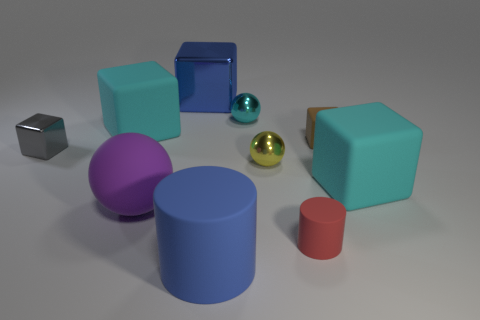There is a cyan object that is on the left side of the small red cylinder and right of the big blue cylinder; what is its size?
Your answer should be compact. Small. Are there fewer tiny yellow metal things to the left of the yellow metal thing than small yellow spheres?
Keep it short and to the point. Yes. Are the big cylinder and the big blue block made of the same material?
Offer a terse response. No. What number of objects are either tiny brown cubes or large blue metallic objects?
Make the answer very short. 2. What number of big cubes have the same material as the yellow thing?
Make the answer very short. 1. The blue object that is the same shape as the small gray metallic object is what size?
Give a very brief answer. Large. There is a tiny brown matte cube; are there any tiny metal things left of it?
Your answer should be very brief. Yes. What material is the brown object?
Your answer should be very brief. Rubber. There is a small ball that is in front of the tiny brown object; does it have the same color as the large metallic cube?
Make the answer very short. No. Is there any other thing that is the same shape as the cyan metallic object?
Provide a short and direct response. Yes. 